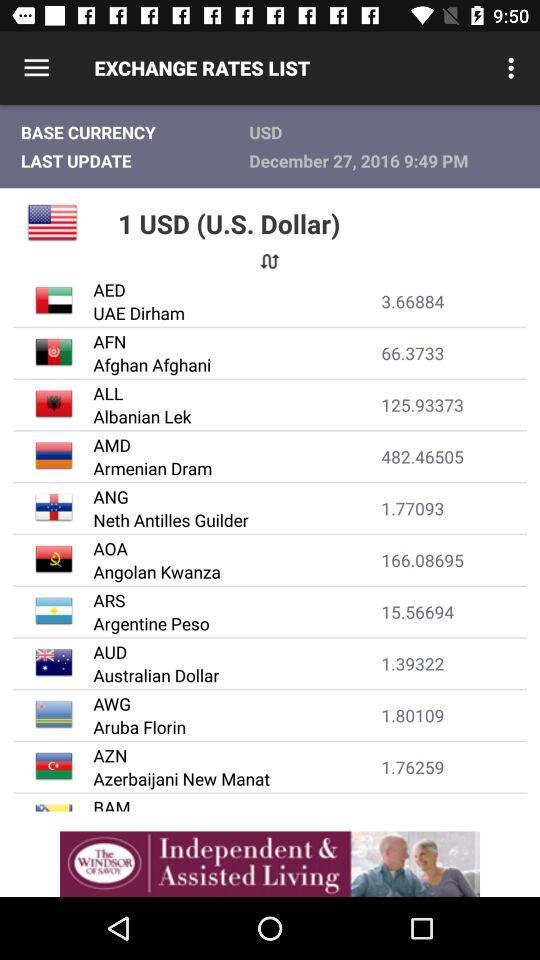What is the base currency? The base currency is the USD. 